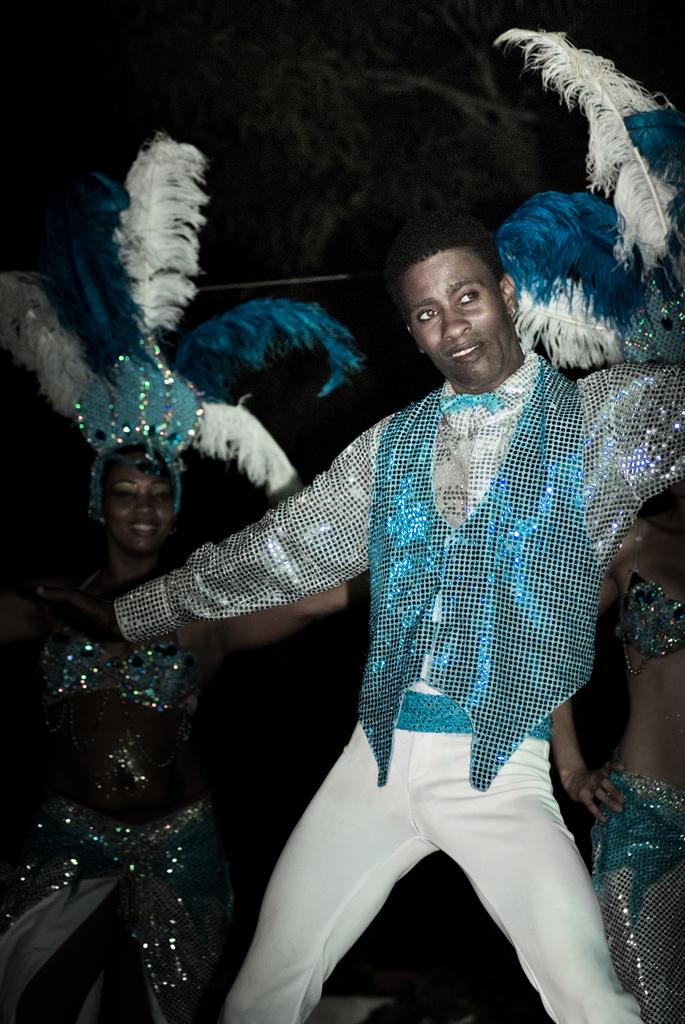What are the people in the image doing? The people in the image are dancing. Can you describe the background of the image? The background of the image is dark. What type of vessel is being used by the people in the image? There is no vessel present in the image; the people are dancing. What material is the leather used for in the image? There is no leather present in the image. 